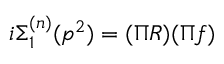Convert formula to latex. <formula><loc_0><loc_0><loc_500><loc_500>i \Sigma _ { 1 } ^ { ( n ) } ( p ^ { 2 } ) = ( \Pi R ) ( \Pi f )</formula> 